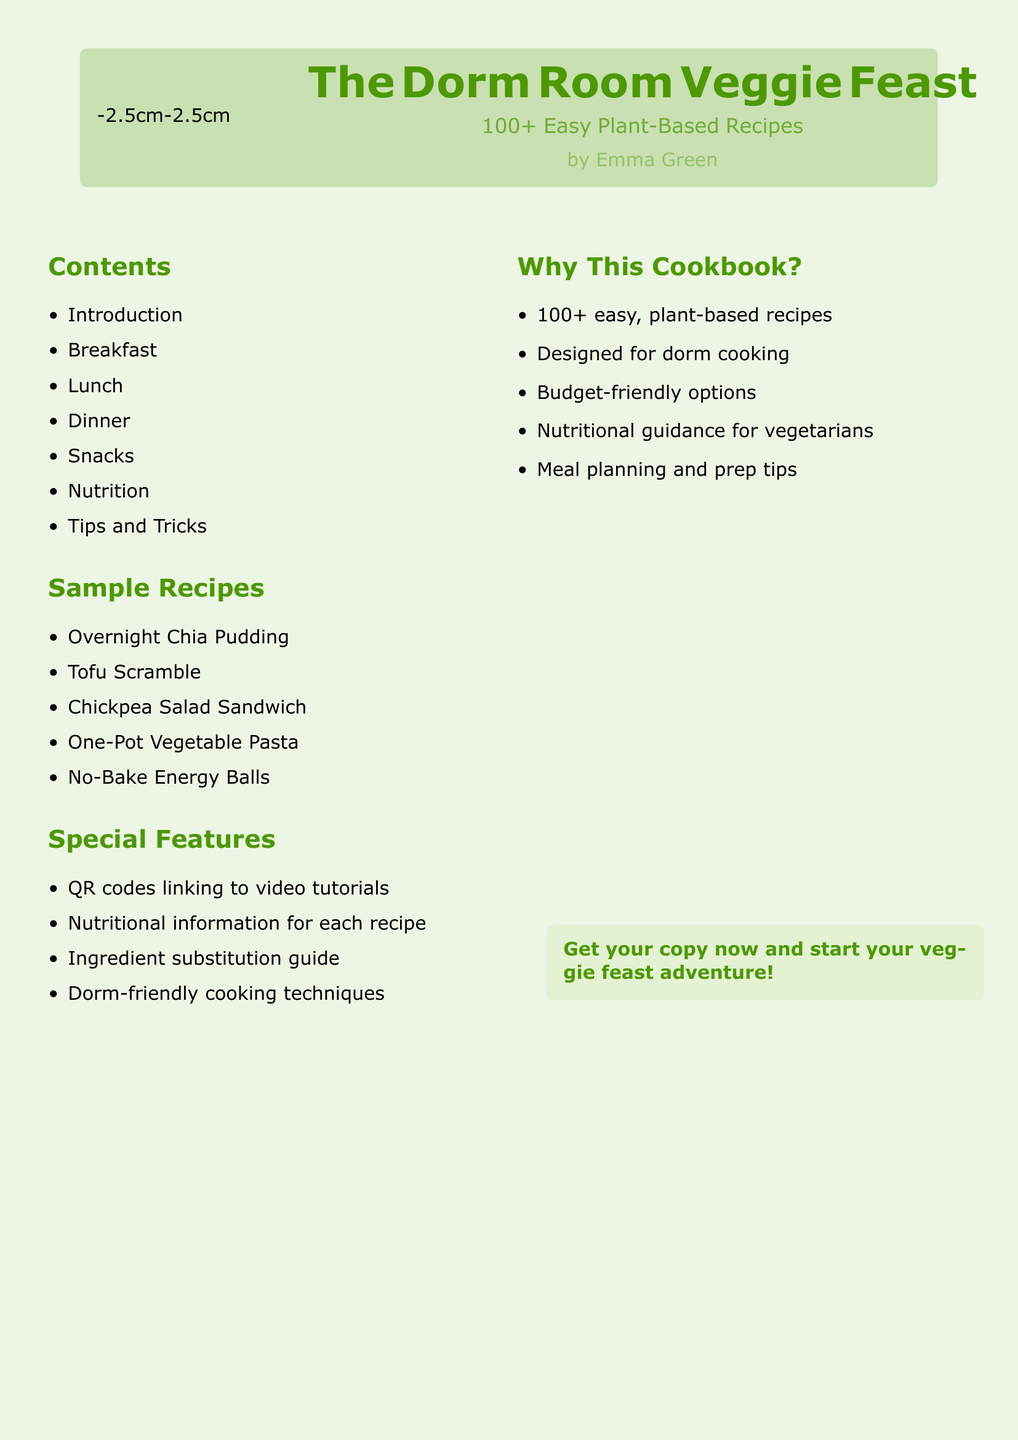What is the title of the cookbook? The title is prominently displayed at the top of the document.
Answer: The Dorm Room Veggie Feast How many recipes are featured in the cookbook? The number of recipes is stated in the subtitle.
Answer: 100+ Who is the author of the cookbook? The author's name is included below the title.
Answer: Emma Green What type of recipes does this cookbook focus on? The focus of the recipes is indicated in the subtitle.
Answer: Plant-Based What section follows "Lunch" in the table of contents? The structure of the contents is organized in a list.
Answer: Dinner Name one special feature of the cookbook. The special features are listed in a specific section.
Answer: QR codes linking to video tutorials What is one aspect the cookbook emphasizes for cooking? The emphasis is highlighted in the special features section.
Answer: Dorm-friendly cooking techniques Does the cookbook provide nutritional information? The contents include a section that discusses nutrition.
Answer: Yes What are the sample recipes listed in the document? Sample recipes are provided in a dedicated section.
Answer: Overnight Chia Pudding, Tofu Scramble, Chickpea Salad Sandwich, One-Pot Vegetable Pasta, No-Bake Energy Balls 